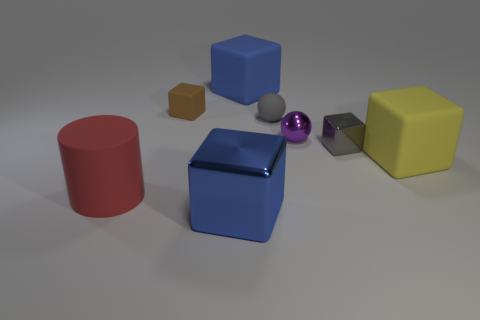Subtract 3 cubes. How many cubes are left? 2 Subtract all yellow cubes. How many cubes are left? 4 Subtract all small gray cubes. How many cubes are left? 4 Subtract all cyan blocks. Subtract all yellow spheres. How many blocks are left? 5 Subtract all cylinders. How many objects are left? 7 Add 6 big green rubber blocks. How many big green rubber blocks exist? 6 Subtract 0 cyan blocks. How many objects are left? 8 Subtract all large green rubber cylinders. Subtract all brown cubes. How many objects are left? 7 Add 6 brown matte blocks. How many brown matte blocks are left? 7 